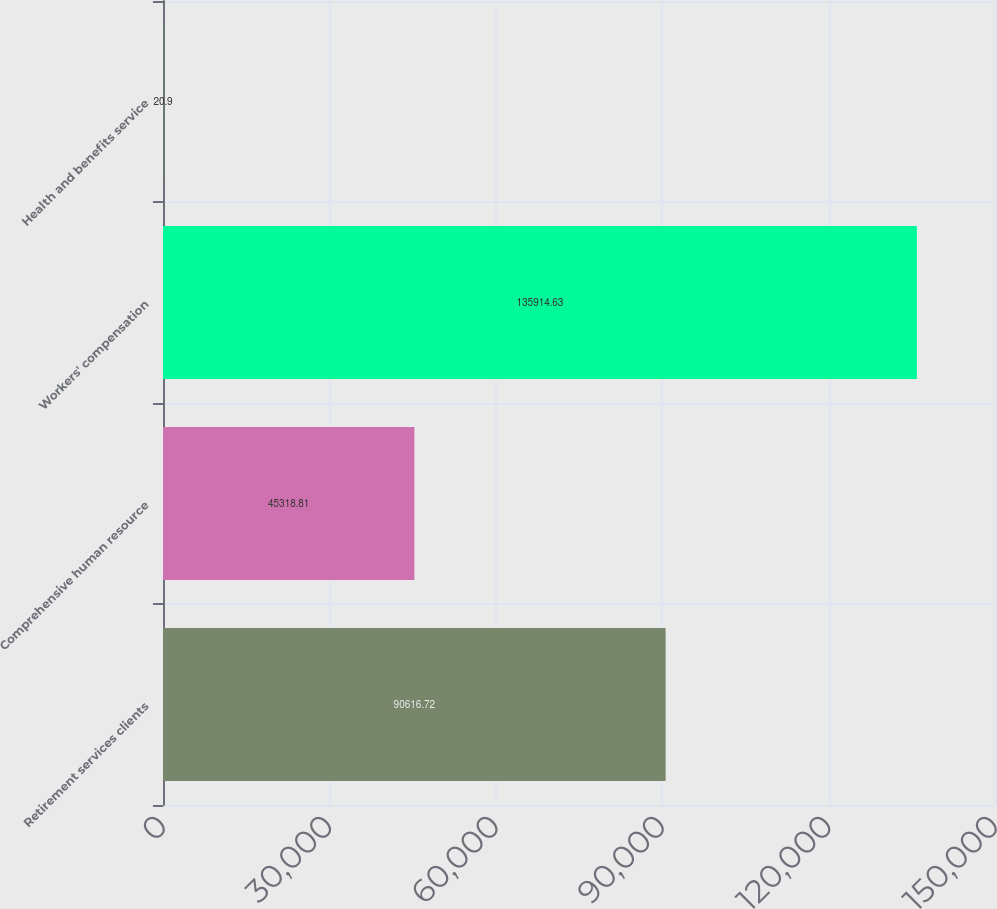<chart> <loc_0><loc_0><loc_500><loc_500><bar_chart><fcel>Retirement services clients<fcel>Comprehensive human resource<fcel>Workers' compensation<fcel>Health and benefits service<nl><fcel>90616.7<fcel>45318.8<fcel>135915<fcel>20.9<nl></chart> 